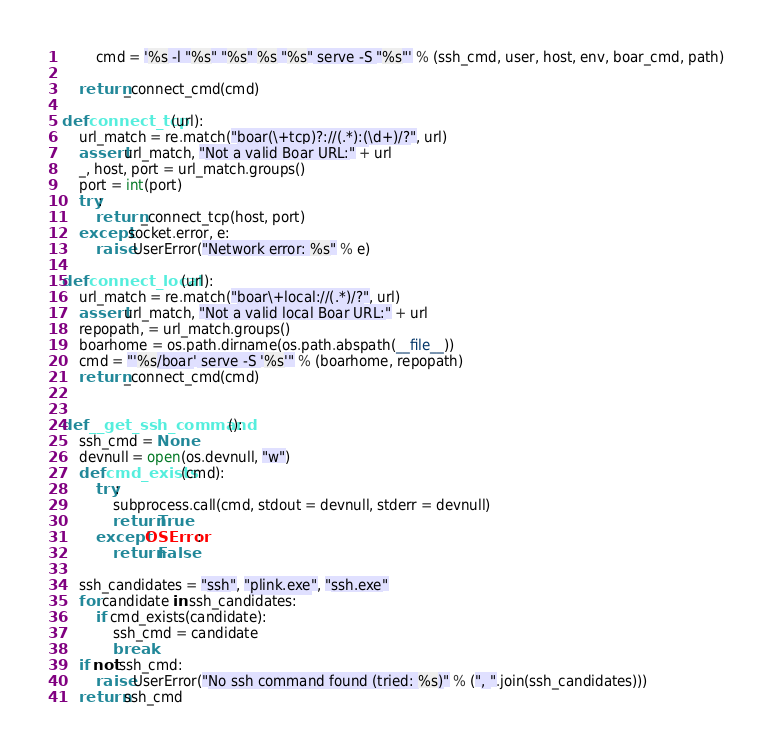<code> <loc_0><loc_0><loc_500><loc_500><_Python_>        cmd = '%s -l "%s" "%s" %s "%s" serve -S "%s"' % (ssh_cmd, user, host, env, boar_cmd, path)

    return _connect_cmd(cmd)

def connect_tcp(url):
    url_match = re.match("boar(\+tcp)?://(.*):(\d+)/?", url)
    assert url_match, "Not a valid Boar URL:" + url
    _, host, port = url_match.groups()
    port = int(port)
    try:
        return _connect_tcp(host, port)
    except socket.error, e:
        raise UserError("Network error: %s" % e)

def connect_local(url):
    url_match = re.match("boar\+local://(.*)/?", url)
    assert url_match, "Not a valid local Boar URL:" + url
    repopath, = url_match.groups()
    boarhome = os.path.dirname(os.path.abspath(__file__))
    cmd = "'%s/boar' serve -S '%s'" % (boarhome, repopath)
    return _connect_cmd(cmd)


def __get_ssh_command():
    ssh_cmd = None
    devnull = open(os.devnull, "w")
    def cmd_exists(cmd):
        try:
            subprocess.call(cmd, stdout = devnull, stderr = devnull)
            return True
        except OSError:
            return False

    ssh_candidates = "ssh", "plink.exe", "ssh.exe"
    for candidate in ssh_candidates:
        if cmd_exists(candidate):
            ssh_cmd = candidate
            break
    if not ssh_cmd:
        raise UserError("No ssh command found (tried: %s)" % (", ".join(ssh_candidates)))
    return ssh_cmd
</code> 